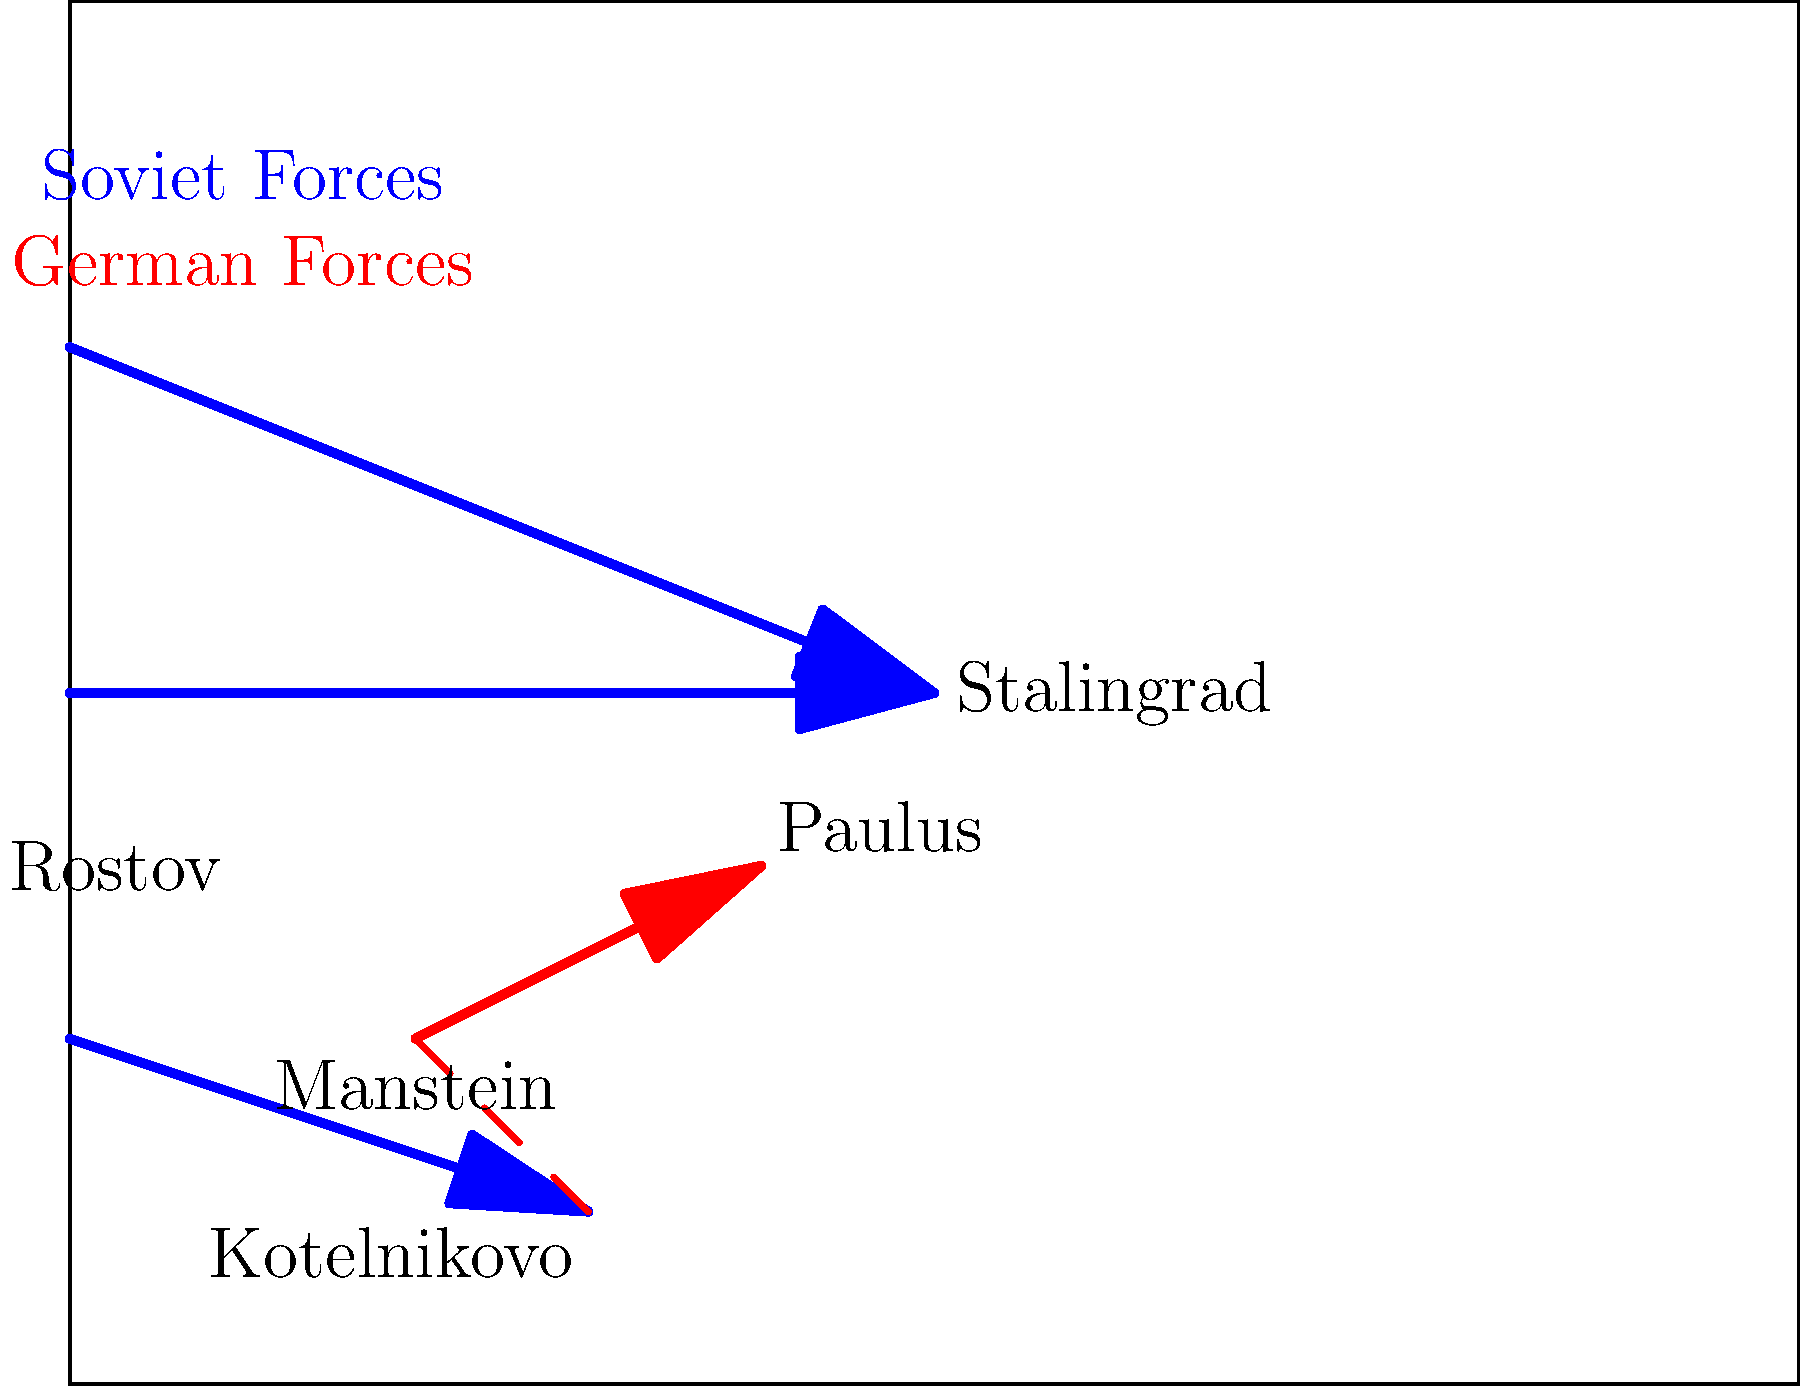Analyze the Soviet counteroffensive at Stalingrad using the troop movement diagram. What was the primary strategic objective of the Soviet pincer movement, and how did it affect Field Marshal Erich von Manstein's relief attempt? 1. Soviet Pincer Movement:
   - The diagram shows Soviet forces (blue arrows) converging on Stalingrad from multiple directions.
   - Two arrows from the north and one from the south-west indicate a classic pincer movement.

2. Strategic Objective:
   - The primary goal was to encircle and trap the German 6th Army under General Paulus in Stalingrad.
   - By attacking from multiple directions, the Soviets aimed to cut off all escape routes and supply lines.

3. Manstein's Relief Attempt:
   - The red arrow from Manstein towards Paulus represents von Manstein's attempt to break through to the encircled 6th Army.
   - The dashed line from Kotelnikovo to Manstein suggests the original planned route of advance.

4. Soviet Counter to Manstein:
   - The blue arrow moving towards Kotelnikovo indicates a Soviet push to intercept Manstein's relief force.
   - This movement threatened to cut off Manstein's own supply lines and force him to retreat.

5. Effect on Manstein's Operation:
   - The Soviet movement towards Kotelnikovo forced Manstein to divert forces to protect his southern flank.
   - This diversion weakened his main thrust towards Stalingrad, ultimately leading to the failure of the relief attempt.

6. Overall Impact:
   - The Soviet pincer movement successfully isolated the 6th Army in Stalingrad.
   - By countering Manstein's relief attempt, the Soviets ensured the encirclement remained intact.
   - This strategy led to the eventual surrender of the 6th Army, marking a turning point in World War II on the Eastern Front.
Answer: Encircle the 6th Army; prevented Manstein's relief by threatening his flank. 